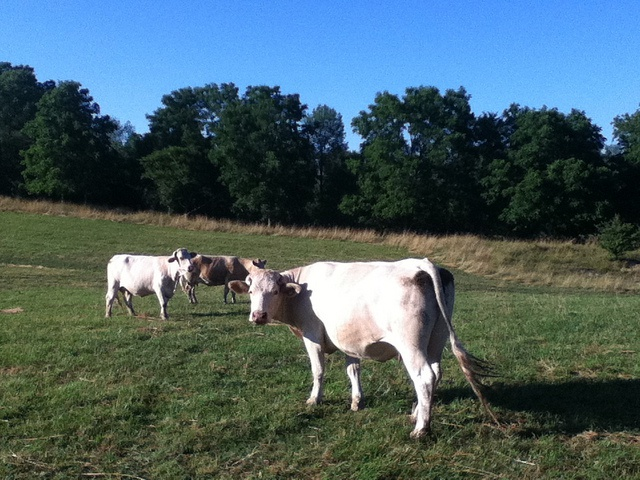Describe the objects in this image and their specific colors. I can see cow in lightblue, white, black, gray, and darkgray tones, cow in lightblue, white, gray, darkgray, and black tones, and cow in lightblue, black, gray, darkgray, and lightgray tones in this image. 